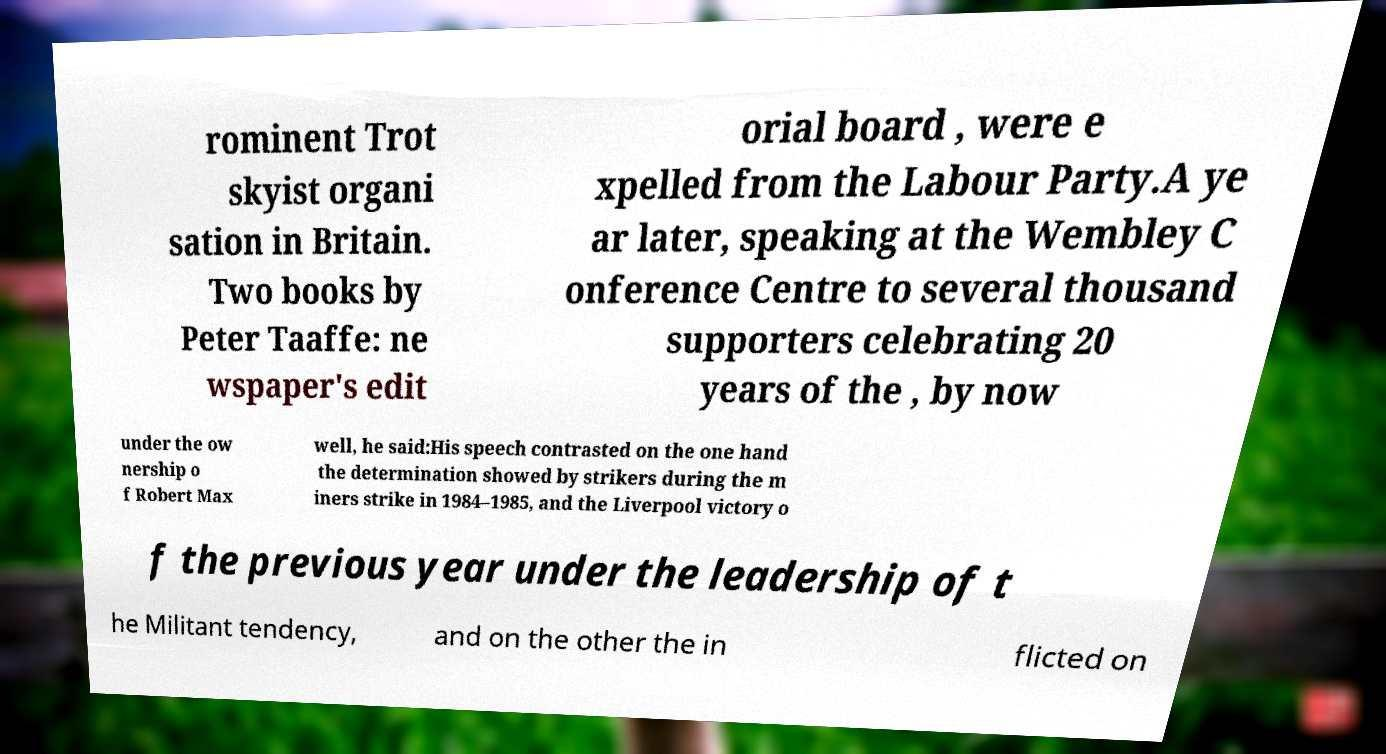Can you read and provide the text displayed in the image?This photo seems to have some interesting text. Can you extract and type it out for me? rominent Trot skyist organi sation in Britain. Two books by Peter Taaffe: ne wspaper's edit orial board , were e xpelled from the Labour Party.A ye ar later, speaking at the Wembley C onference Centre to several thousand supporters celebrating 20 years of the , by now under the ow nership o f Robert Max well, he said:His speech contrasted on the one hand the determination showed by strikers during the m iners strike in 1984–1985, and the Liverpool victory o f the previous year under the leadership of t he Militant tendency, and on the other the in flicted on 